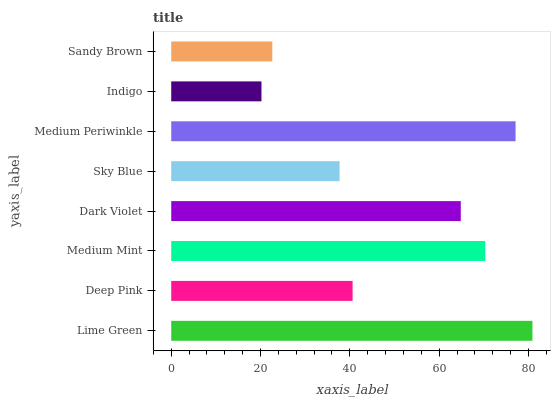Is Indigo the minimum?
Answer yes or no. Yes. Is Lime Green the maximum?
Answer yes or no. Yes. Is Deep Pink the minimum?
Answer yes or no. No. Is Deep Pink the maximum?
Answer yes or no. No. Is Lime Green greater than Deep Pink?
Answer yes or no. Yes. Is Deep Pink less than Lime Green?
Answer yes or no. Yes. Is Deep Pink greater than Lime Green?
Answer yes or no. No. Is Lime Green less than Deep Pink?
Answer yes or no. No. Is Dark Violet the high median?
Answer yes or no. Yes. Is Deep Pink the low median?
Answer yes or no. Yes. Is Medium Mint the high median?
Answer yes or no. No. Is Indigo the low median?
Answer yes or no. No. 